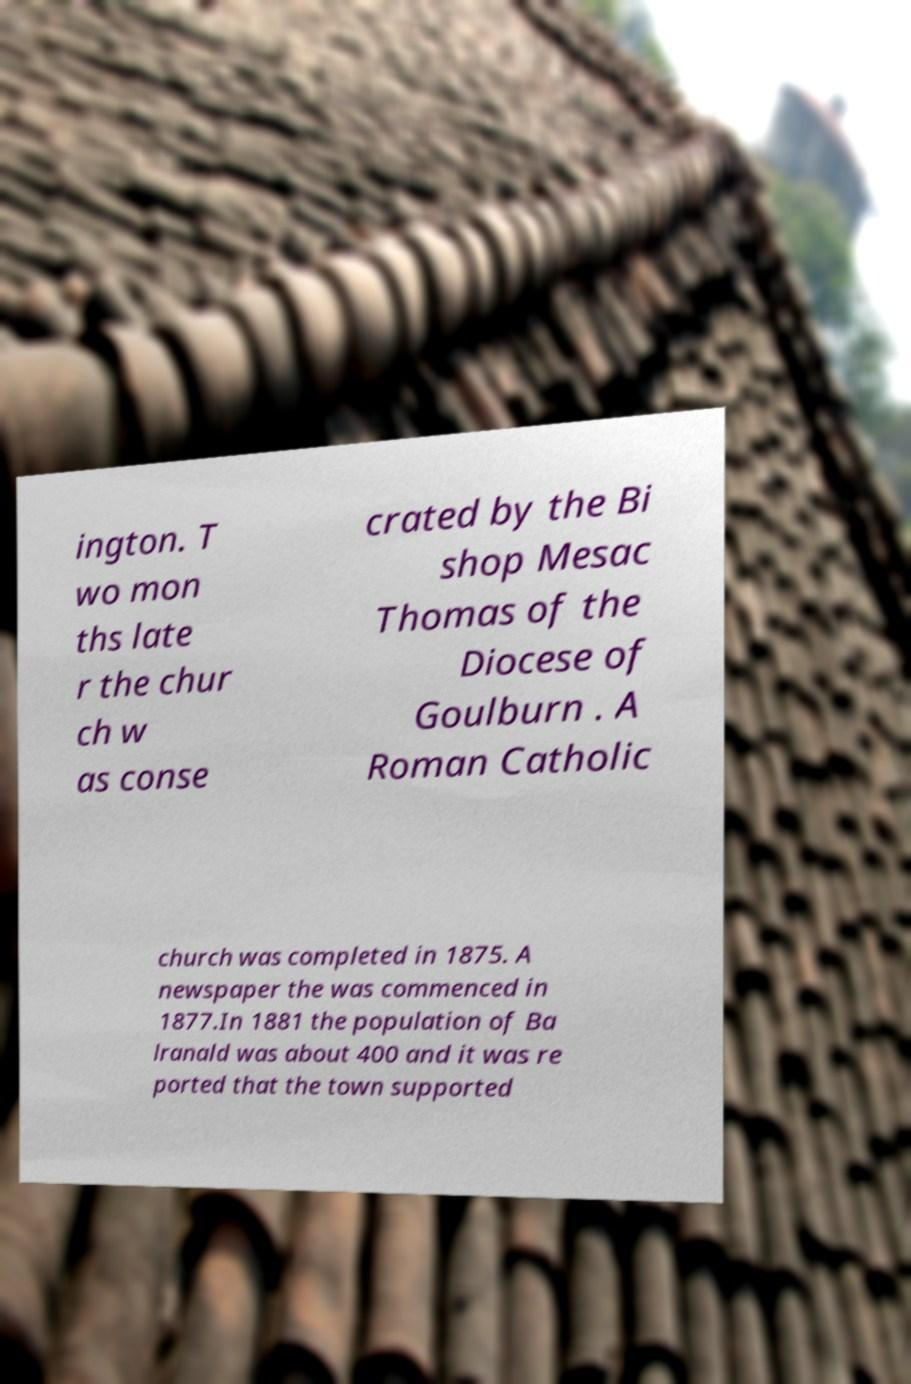Please read and relay the text visible in this image. What does it say? ington. T wo mon ths late r the chur ch w as conse crated by the Bi shop Mesac Thomas of the Diocese of Goulburn . A Roman Catholic church was completed in 1875. A newspaper the was commenced in 1877.In 1881 the population of Ba lranald was about 400 and it was re ported that the town supported 